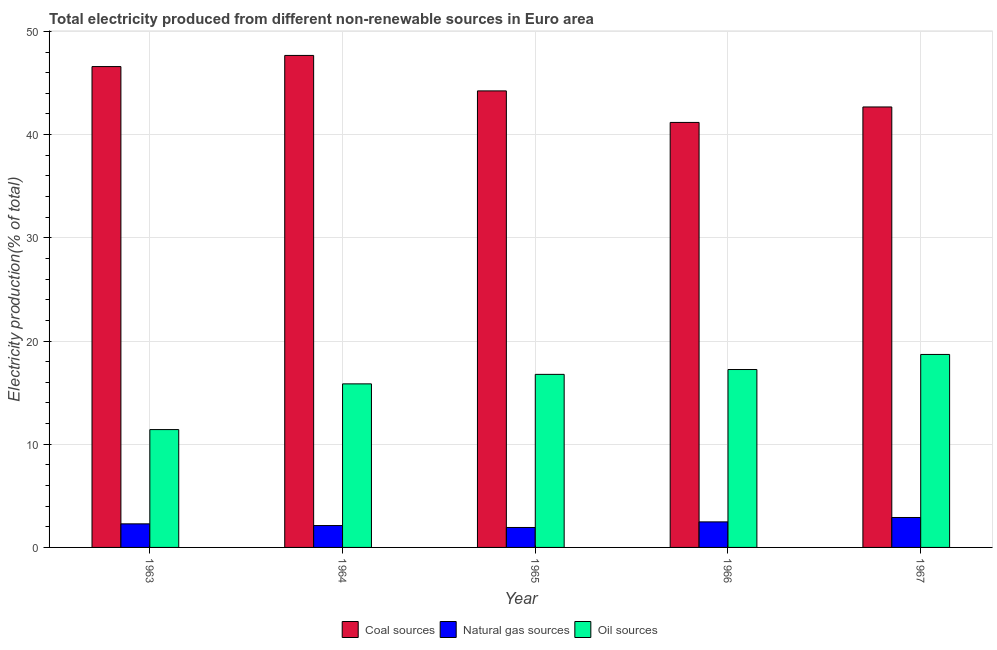How many different coloured bars are there?
Your response must be concise. 3. Are the number of bars per tick equal to the number of legend labels?
Ensure brevity in your answer.  Yes. Are the number of bars on each tick of the X-axis equal?
Give a very brief answer. Yes. How many bars are there on the 1st tick from the left?
Ensure brevity in your answer.  3. How many bars are there on the 4th tick from the right?
Keep it short and to the point. 3. What is the label of the 2nd group of bars from the left?
Make the answer very short. 1964. In how many cases, is the number of bars for a given year not equal to the number of legend labels?
Offer a very short reply. 0. What is the percentage of electricity produced by natural gas in 1965?
Keep it short and to the point. 1.93. Across all years, what is the maximum percentage of electricity produced by natural gas?
Keep it short and to the point. 2.9. Across all years, what is the minimum percentage of electricity produced by natural gas?
Make the answer very short. 1.93. In which year was the percentage of electricity produced by oil sources maximum?
Keep it short and to the point. 1967. In which year was the percentage of electricity produced by coal minimum?
Make the answer very short. 1966. What is the total percentage of electricity produced by oil sources in the graph?
Your answer should be very brief. 79.97. What is the difference between the percentage of electricity produced by oil sources in 1963 and that in 1967?
Your response must be concise. -7.28. What is the difference between the percentage of electricity produced by oil sources in 1966 and the percentage of electricity produced by natural gas in 1965?
Your answer should be very brief. 0.47. What is the average percentage of electricity produced by coal per year?
Offer a terse response. 44.47. In the year 1967, what is the difference between the percentage of electricity produced by coal and percentage of electricity produced by oil sources?
Your answer should be compact. 0. In how many years, is the percentage of electricity produced by natural gas greater than 36 %?
Your answer should be very brief. 0. What is the ratio of the percentage of electricity produced by natural gas in 1965 to that in 1966?
Your answer should be compact. 0.78. Is the percentage of electricity produced by natural gas in 1966 less than that in 1967?
Ensure brevity in your answer.  Yes. Is the difference between the percentage of electricity produced by oil sources in 1965 and 1967 greater than the difference between the percentage of electricity produced by coal in 1965 and 1967?
Provide a succinct answer. No. What is the difference between the highest and the second highest percentage of electricity produced by natural gas?
Make the answer very short. 0.43. What is the difference between the highest and the lowest percentage of electricity produced by coal?
Give a very brief answer. 6.49. In how many years, is the percentage of electricity produced by natural gas greater than the average percentage of electricity produced by natural gas taken over all years?
Ensure brevity in your answer.  2. Is the sum of the percentage of electricity produced by natural gas in 1963 and 1964 greater than the maximum percentage of electricity produced by coal across all years?
Provide a succinct answer. Yes. What does the 1st bar from the left in 1966 represents?
Your response must be concise. Coal sources. What does the 2nd bar from the right in 1967 represents?
Offer a very short reply. Natural gas sources. How many bars are there?
Your answer should be compact. 15. Are the values on the major ticks of Y-axis written in scientific E-notation?
Offer a very short reply. No. Does the graph contain any zero values?
Your answer should be very brief. No. Where does the legend appear in the graph?
Keep it short and to the point. Bottom center. How are the legend labels stacked?
Offer a terse response. Horizontal. What is the title of the graph?
Offer a terse response. Total electricity produced from different non-renewable sources in Euro area. Does "Solid fuel" appear as one of the legend labels in the graph?
Your answer should be compact. No. What is the Electricity production(% of total) in Coal sources in 1963?
Ensure brevity in your answer.  46.59. What is the Electricity production(% of total) in Natural gas sources in 1963?
Offer a very short reply. 2.28. What is the Electricity production(% of total) of Oil sources in 1963?
Your answer should be compact. 11.42. What is the Electricity production(% of total) in Coal sources in 1964?
Make the answer very short. 47.67. What is the Electricity production(% of total) in Natural gas sources in 1964?
Provide a short and direct response. 2.12. What is the Electricity production(% of total) of Oil sources in 1964?
Ensure brevity in your answer.  15.85. What is the Electricity production(% of total) of Coal sources in 1965?
Offer a very short reply. 44.23. What is the Electricity production(% of total) in Natural gas sources in 1965?
Give a very brief answer. 1.93. What is the Electricity production(% of total) of Oil sources in 1965?
Your response must be concise. 16.77. What is the Electricity production(% of total) in Coal sources in 1966?
Offer a very short reply. 41.18. What is the Electricity production(% of total) of Natural gas sources in 1966?
Make the answer very short. 2.47. What is the Electricity production(% of total) of Oil sources in 1966?
Make the answer very short. 17.24. What is the Electricity production(% of total) of Coal sources in 1967?
Give a very brief answer. 42.68. What is the Electricity production(% of total) in Natural gas sources in 1967?
Your answer should be very brief. 2.9. What is the Electricity production(% of total) in Oil sources in 1967?
Offer a terse response. 18.7. Across all years, what is the maximum Electricity production(% of total) of Coal sources?
Give a very brief answer. 47.67. Across all years, what is the maximum Electricity production(% of total) in Natural gas sources?
Provide a short and direct response. 2.9. Across all years, what is the maximum Electricity production(% of total) in Oil sources?
Make the answer very short. 18.7. Across all years, what is the minimum Electricity production(% of total) of Coal sources?
Your response must be concise. 41.18. Across all years, what is the minimum Electricity production(% of total) of Natural gas sources?
Provide a succinct answer. 1.93. Across all years, what is the minimum Electricity production(% of total) in Oil sources?
Your answer should be very brief. 11.42. What is the total Electricity production(% of total) in Coal sources in the graph?
Ensure brevity in your answer.  222.35. What is the total Electricity production(% of total) of Natural gas sources in the graph?
Provide a succinct answer. 11.71. What is the total Electricity production(% of total) in Oil sources in the graph?
Your answer should be very brief. 79.97. What is the difference between the Electricity production(% of total) in Coal sources in 1963 and that in 1964?
Offer a very short reply. -1.08. What is the difference between the Electricity production(% of total) in Natural gas sources in 1963 and that in 1964?
Your answer should be very brief. 0.17. What is the difference between the Electricity production(% of total) of Oil sources in 1963 and that in 1964?
Keep it short and to the point. -4.43. What is the difference between the Electricity production(% of total) of Coal sources in 1963 and that in 1965?
Your answer should be compact. 2.36. What is the difference between the Electricity production(% of total) in Natural gas sources in 1963 and that in 1965?
Provide a succinct answer. 0.35. What is the difference between the Electricity production(% of total) of Oil sources in 1963 and that in 1965?
Ensure brevity in your answer.  -5.35. What is the difference between the Electricity production(% of total) of Coal sources in 1963 and that in 1966?
Provide a short and direct response. 5.41. What is the difference between the Electricity production(% of total) in Natural gas sources in 1963 and that in 1966?
Ensure brevity in your answer.  -0.19. What is the difference between the Electricity production(% of total) in Oil sources in 1963 and that in 1966?
Provide a succinct answer. -5.82. What is the difference between the Electricity production(% of total) in Coal sources in 1963 and that in 1967?
Give a very brief answer. 3.91. What is the difference between the Electricity production(% of total) in Natural gas sources in 1963 and that in 1967?
Your answer should be compact. -0.62. What is the difference between the Electricity production(% of total) in Oil sources in 1963 and that in 1967?
Keep it short and to the point. -7.28. What is the difference between the Electricity production(% of total) in Coal sources in 1964 and that in 1965?
Provide a short and direct response. 3.44. What is the difference between the Electricity production(% of total) of Natural gas sources in 1964 and that in 1965?
Provide a succinct answer. 0.19. What is the difference between the Electricity production(% of total) in Oil sources in 1964 and that in 1965?
Make the answer very short. -0.92. What is the difference between the Electricity production(% of total) in Coal sources in 1964 and that in 1966?
Provide a succinct answer. 6.49. What is the difference between the Electricity production(% of total) in Natural gas sources in 1964 and that in 1966?
Provide a succinct answer. -0.36. What is the difference between the Electricity production(% of total) of Oil sources in 1964 and that in 1966?
Your answer should be compact. -1.39. What is the difference between the Electricity production(% of total) of Coal sources in 1964 and that in 1967?
Your answer should be compact. 4.99. What is the difference between the Electricity production(% of total) of Natural gas sources in 1964 and that in 1967?
Provide a succinct answer. -0.78. What is the difference between the Electricity production(% of total) in Oil sources in 1964 and that in 1967?
Make the answer very short. -2.85. What is the difference between the Electricity production(% of total) of Coal sources in 1965 and that in 1966?
Offer a terse response. 3.06. What is the difference between the Electricity production(% of total) of Natural gas sources in 1965 and that in 1966?
Make the answer very short. -0.54. What is the difference between the Electricity production(% of total) of Oil sources in 1965 and that in 1966?
Your answer should be very brief. -0.47. What is the difference between the Electricity production(% of total) of Coal sources in 1965 and that in 1967?
Keep it short and to the point. 1.56. What is the difference between the Electricity production(% of total) of Natural gas sources in 1965 and that in 1967?
Offer a very short reply. -0.97. What is the difference between the Electricity production(% of total) of Oil sources in 1965 and that in 1967?
Provide a succinct answer. -1.93. What is the difference between the Electricity production(% of total) in Coal sources in 1966 and that in 1967?
Keep it short and to the point. -1.5. What is the difference between the Electricity production(% of total) in Natural gas sources in 1966 and that in 1967?
Give a very brief answer. -0.43. What is the difference between the Electricity production(% of total) in Oil sources in 1966 and that in 1967?
Give a very brief answer. -1.46. What is the difference between the Electricity production(% of total) of Coal sources in 1963 and the Electricity production(% of total) of Natural gas sources in 1964?
Offer a terse response. 44.47. What is the difference between the Electricity production(% of total) in Coal sources in 1963 and the Electricity production(% of total) in Oil sources in 1964?
Keep it short and to the point. 30.74. What is the difference between the Electricity production(% of total) in Natural gas sources in 1963 and the Electricity production(% of total) in Oil sources in 1964?
Ensure brevity in your answer.  -13.56. What is the difference between the Electricity production(% of total) in Coal sources in 1963 and the Electricity production(% of total) in Natural gas sources in 1965?
Provide a succinct answer. 44.66. What is the difference between the Electricity production(% of total) of Coal sources in 1963 and the Electricity production(% of total) of Oil sources in 1965?
Provide a succinct answer. 29.82. What is the difference between the Electricity production(% of total) of Natural gas sources in 1963 and the Electricity production(% of total) of Oil sources in 1965?
Provide a short and direct response. -14.48. What is the difference between the Electricity production(% of total) of Coal sources in 1963 and the Electricity production(% of total) of Natural gas sources in 1966?
Offer a very short reply. 44.12. What is the difference between the Electricity production(% of total) in Coal sources in 1963 and the Electricity production(% of total) in Oil sources in 1966?
Keep it short and to the point. 29.35. What is the difference between the Electricity production(% of total) of Natural gas sources in 1963 and the Electricity production(% of total) of Oil sources in 1966?
Provide a short and direct response. -14.95. What is the difference between the Electricity production(% of total) in Coal sources in 1963 and the Electricity production(% of total) in Natural gas sources in 1967?
Offer a terse response. 43.69. What is the difference between the Electricity production(% of total) of Coal sources in 1963 and the Electricity production(% of total) of Oil sources in 1967?
Ensure brevity in your answer.  27.89. What is the difference between the Electricity production(% of total) of Natural gas sources in 1963 and the Electricity production(% of total) of Oil sources in 1967?
Offer a very short reply. -16.41. What is the difference between the Electricity production(% of total) in Coal sources in 1964 and the Electricity production(% of total) in Natural gas sources in 1965?
Offer a very short reply. 45.74. What is the difference between the Electricity production(% of total) in Coal sources in 1964 and the Electricity production(% of total) in Oil sources in 1965?
Ensure brevity in your answer.  30.9. What is the difference between the Electricity production(% of total) in Natural gas sources in 1964 and the Electricity production(% of total) in Oil sources in 1965?
Ensure brevity in your answer.  -14.65. What is the difference between the Electricity production(% of total) of Coal sources in 1964 and the Electricity production(% of total) of Natural gas sources in 1966?
Your response must be concise. 45.2. What is the difference between the Electricity production(% of total) of Coal sources in 1964 and the Electricity production(% of total) of Oil sources in 1966?
Make the answer very short. 30.43. What is the difference between the Electricity production(% of total) of Natural gas sources in 1964 and the Electricity production(% of total) of Oil sources in 1966?
Your answer should be very brief. -15.12. What is the difference between the Electricity production(% of total) in Coal sources in 1964 and the Electricity production(% of total) in Natural gas sources in 1967?
Provide a succinct answer. 44.77. What is the difference between the Electricity production(% of total) of Coal sources in 1964 and the Electricity production(% of total) of Oil sources in 1967?
Give a very brief answer. 28.97. What is the difference between the Electricity production(% of total) of Natural gas sources in 1964 and the Electricity production(% of total) of Oil sources in 1967?
Keep it short and to the point. -16.58. What is the difference between the Electricity production(% of total) in Coal sources in 1965 and the Electricity production(% of total) in Natural gas sources in 1966?
Give a very brief answer. 41.76. What is the difference between the Electricity production(% of total) in Coal sources in 1965 and the Electricity production(% of total) in Oil sources in 1966?
Provide a short and direct response. 27. What is the difference between the Electricity production(% of total) of Natural gas sources in 1965 and the Electricity production(% of total) of Oil sources in 1966?
Your answer should be very brief. -15.3. What is the difference between the Electricity production(% of total) in Coal sources in 1965 and the Electricity production(% of total) in Natural gas sources in 1967?
Provide a succinct answer. 41.33. What is the difference between the Electricity production(% of total) of Coal sources in 1965 and the Electricity production(% of total) of Oil sources in 1967?
Provide a short and direct response. 25.54. What is the difference between the Electricity production(% of total) in Natural gas sources in 1965 and the Electricity production(% of total) in Oil sources in 1967?
Keep it short and to the point. -16.76. What is the difference between the Electricity production(% of total) in Coal sources in 1966 and the Electricity production(% of total) in Natural gas sources in 1967?
Make the answer very short. 38.28. What is the difference between the Electricity production(% of total) of Coal sources in 1966 and the Electricity production(% of total) of Oil sources in 1967?
Offer a terse response. 22.48. What is the difference between the Electricity production(% of total) of Natural gas sources in 1966 and the Electricity production(% of total) of Oil sources in 1967?
Make the answer very short. -16.22. What is the average Electricity production(% of total) in Coal sources per year?
Provide a short and direct response. 44.47. What is the average Electricity production(% of total) of Natural gas sources per year?
Keep it short and to the point. 2.34. What is the average Electricity production(% of total) of Oil sources per year?
Offer a very short reply. 15.99. In the year 1963, what is the difference between the Electricity production(% of total) in Coal sources and Electricity production(% of total) in Natural gas sources?
Offer a very short reply. 44.31. In the year 1963, what is the difference between the Electricity production(% of total) in Coal sources and Electricity production(% of total) in Oil sources?
Provide a short and direct response. 35.17. In the year 1963, what is the difference between the Electricity production(% of total) in Natural gas sources and Electricity production(% of total) in Oil sources?
Ensure brevity in your answer.  -9.13. In the year 1964, what is the difference between the Electricity production(% of total) of Coal sources and Electricity production(% of total) of Natural gas sources?
Ensure brevity in your answer.  45.55. In the year 1964, what is the difference between the Electricity production(% of total) of Coal sources and Electricity production(% of total) of Oil sources?
Make the answer very short. 31.82. In the year 1964, what is the difference between the Electricity production(% of total) in Natural gas sources and Electricity production(% of total) in Oil sources?
Offer a terse response. -13.73. In the year 1965, what is the difference between the Electricity production(% of total) in Coal sources and Electricity production(% of total) in Natural gas sources?
Provide a short and direct response. 42.3. In the year 1965, what is the difference between the Electricity production(% of total) of Coal sources and Electricity production(% of total) of Oil sources?
Make the answer very short. 27.46. In the year 1965, what is the difference between the Electricity production(% of total) of Natural gas sources and Electricity production(% of total) of Oil sources?
Give a very brief answer. -14.84. In the year 1966, what is the difference between the Electricity production(% of total) in Coal sources and Electricity production(% of total) in Natural gas sources?
Give a very brief answer. 38.7. In the year 1966, what is the difference between the Electricity production(% of total) of Coal sources and Electricity production(% of total) of Oil sources?
Make the answer very short. 23.94. In the year 1966, what is the difference between the Electricity production(% of total) of Natural gas sources and Electricity production(% of total) of Oil sources?
Give a very brief answer. -14.76. In the year 1967, what is the difference between the Electricity production(% of total) in Coal sources and Electricity production(% of total) in Natural gas sources?
Ensure brevity in your answer.  39.78. In the year 1967, what is the difference between the Electricity production(% of total) of Coal sources and Electricity production(% of total) of Oil sources?
Provide a succinct answer. 23.98. In the year 1967, what is the difference between the Electricity production(% of total) of Natural gas sources and Electricity production(% of total) of Oil sources?
Provide a short and direct response. -15.8. What is the ratio of the Electricity production(% of total) of Coal sources in 1963 to that in 1964?
Make the answer very short. 0.98. What is the ratio of the Electricity production(% of total) in Natural gas sources in 1963 to that in 1964?
Your answer should be compact. 1.08. What is the ratio of the Electricity production(% of total) of Oil sources in 1963 to that in 1964?
Offer a terse response. 0.72. What is the ratio of the Electricity production(% of total) of Coal sources in 1963 to that in 1965?
Offer a very short reply. 1.05. What is the ratio of the Electricity production(% of total) in Natural gas sources in 1963 to that in 1965?
Your answer should be compact. 1.18. What is the ratio of the Electricity production(% of total) of Oil sources in 1963 to that in 1965?
Offer a very short reply. 0.68. What is the ratio of the Electricity production(% of total) of Coal sources in 1963 to that in 1966?
Your answer should be very brief. 1.13. What is the ratio of the Electricity production(% of total) of Natural gas sources in 1963 to that in 1966?
Ensure brevity in your answer.  0.92. What is the ratio of the Electricity production(% of total) in Oil sources in 1963 to that in 1966?
Make the answer very short. 0.66. What is the ratio of the Electricity production(% of total) in Coal sources in 1963 to that in 1967?
Offer a very short reply. 1.09. What is the ratio of the Electricity production(% of total) of Natural gas sources in 1963 to that in 1967?
Your response must be concise. 0.79. What is the ratio of the Electricity production(% of total) in Oil sources in 1963 to that in 1967?
Provide a succinct answer. 0.61. What is the ratio of the Electricity production(% of total) in Coal sources in 1964 to that in 1965?
Offer a very short reply. 1.08. What is the ratio of the Electricity production(% of total) in Natural gas sources in 1964 to that in 1965?
Provide a short and direct response. 1.1. What is the ratio of the Electricity production(% of total) of Oil sources in 1964 to that in 1965?
Offer a terse response. 0.94. What is the ratio of the Electricity production(% of total) in Coal sources in 1964 to that in 1966?
Give a very brief answer. 1.16. What is the ratio of the Electricity production(% of total) in Natural gas sources in 1964 to that in 1966?
Your answer should be compact. 0.86. What is the ratio of the Electricity production(% of total) of Oil sources in 1964 to that in 1966?
Provide a short and direct response. 0.92. What is the ratio of the Electricity production(% of total) of Coal sources in 1964 to that in 1967?
Ensure brevity in your answer.  1.12. What is the ratio of the Electricity production(% of total) in Natural gas sources in 1964 to that in 1967?
Offer a very short reply. 0.73. What is the ratio of the Electricity production(% of total) of Oil sources in 1964 to that in 1967?
Provide a succinct answer. 0.85. What is the ratio of the Electricity production(% of total) of Coal sources in 1965 to that in 1966?
Your answer should be very brief. 1.07. What is the ratio of the Electricity production(% of total) in Natural gas sources in 1965 to that in 1966?
Your response must be concise. 0.78. What is the ratio of the Electricity production(% of total) in Oil sources in 1965 to that in 1966?
Your answer should be very brief. 0.97. What is the ratio of the Electricity production(% of total) of Coal sources in 1965 to that in 1967?
Ensure brevity in your answer.  1.04. What is the ratio of the Electricity production(% of total) of Natural gas sources in 1965 to that in 1967?
Make the answer very short. 0.67. What is the ratio of the Electricity production(% of total) in Oil sources in 1965 to that in 1967?
Give a very brief answer. 0.9. What is the ratio of the Electricity production(% of total) in Coal sources in 1966 to that in 1967?
Your answer should be compact. 0.96. What is the ratio of the Electricity production(% of total) in Natural gas sources in 1966 to that in 1967?
Provide a short and direct response. 0.85. What is the ratio of the Electricity production(% of total) in Oil sources in 1966 to that in 1967?
Offer a very short reply. 0.92. What is the difference between the highest and the second highest Electricity production(% of total) of Coal sources?
Your answer should be very brief. 1.08. What is the difference between the highest and the second highest Electricity production(% of total) of Natural gas sources?
Make the answer very short. 0.43. What is the difference between the highest and the second highest Electricity production(% of total) of Oil sources?
Keep it short and to the point. 1.46. What is the difference between the highest and the lowest Electricity production(% of total) of Coal sources?
Provide a succinct answer. 6.49. What is the difference between the highest and the lowest Electricity production(% of total) in Natural gas sources?
Provide a succinct answer. 0.97. What is the difference between the highest and the lowest Electricity production(% of total) of Oil sources?
Your answer should be very brief. 7.28. 